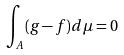<formula> <loc_0><loc_0><loc_500><loc_500>\int _ { A } ( g - f ) d \mu = 0</formula> 